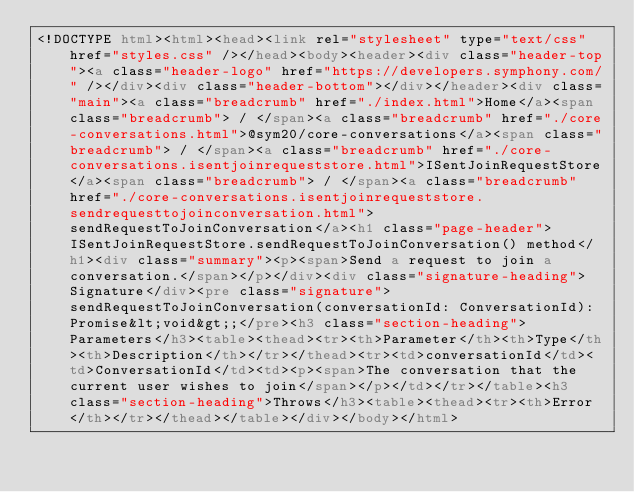Convert code to text. <code><loc_0><loc_0><loc_500><loc_500><_HTML_><!DOCTYPE html><html><head><link rel="stylesheet" type="text/css" href="styles.css" /></head><body><header><div class="header-top"><a class="header-logo" href="https://developers.symphony.com/" /></div><div class="header-bottom"></div></header><div class="main"><a class="breadcrumb" href="./index.html">Home</a><span class="breadcrumb"> / </span><a class="breadcrumb" href="./core-conversations.html">@sym20/core-conversations</a><span class="breadcrumb"> / </span><a class="breadcrumb" href="./core-conversations.isentjoinrequeststore.html">ISentJoinRequestStore</a><span class="breadcrumb"> / </span><a class="breadcrumb" href="./core-conversations.isentjoinrequeststore.sendrequesttojoinconversation.html">sendRequestToJoinConversation</a><h1 class="page-header">ISentJoinRequestStore.sendRequestToJoinConversation() method</h1><div class="summary"><p><span>Send a request to join a conversation.</span></p></div><div class="signature-heading">Signature</div><pre class="signature">sendRequestToJoinConversation(conversationId: ConversationId): Promise&lt;void&gt;;</pre><h3 class="section-heading">Parameters</h3><table><thead><tr><th>Parameter</th><th>Type</th><th>Description</th></tr></thead><tr><td>conversationId</td><td>ConversationId</td><td><p><span>The conversation that the current user wishes to join</span></p></td></tr></table><h3 class="section-heading">Throws</h3><table><thead><tr><th>Error</th></tr></thead></table></div></body></html></code> 